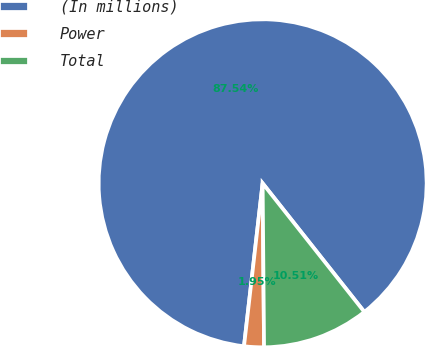<chart> <loc_0><loc_0><loc_500><loc_500><pie_chart><fcel>(In millions)<fcel>Power<fcel>Total<nl><fcel>87.53%<fcel>1.95%<fcel>10.51%<nl></chart> 